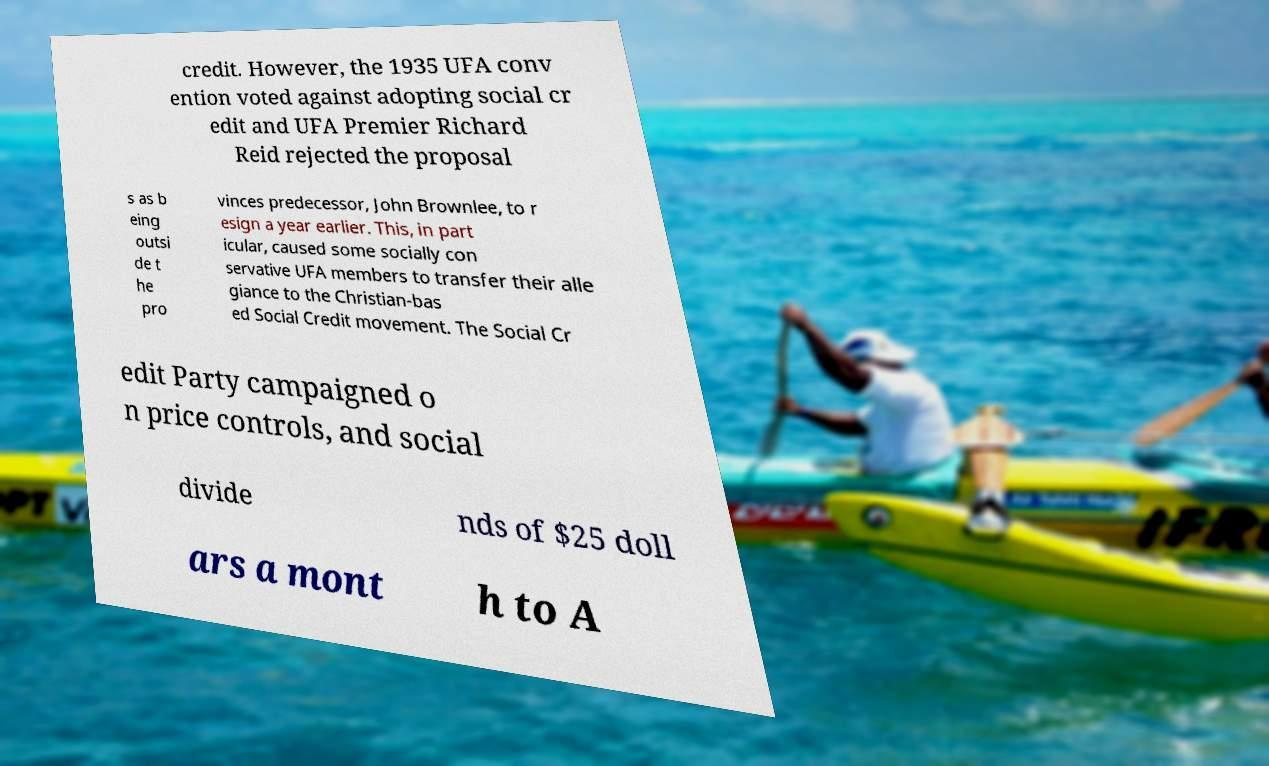What messages or text are displayed in this image? I need them in a readable, typed format. credit. However, the 1935 UFA conv ention voted against adopting social cr edit and UFA Premier Richard Reid rejected the proposal s as b eing outsi de t he pro vinces predecessor, John Brownlee, to r esign a year earlier. This, in part icular, caused some socially con servative UFA members to transfer their alle giance to the Christian-bas ed Social Credit movement. The Social Cr edit Party campaigned o n price controls, and social divide nds of $25 doll ars a mont h to A 